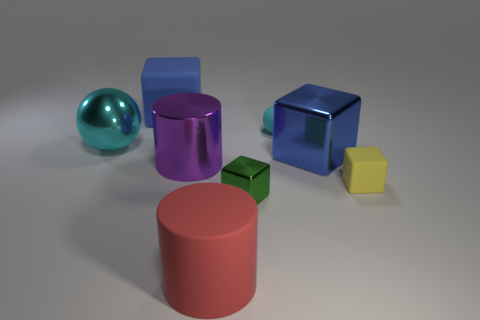Can you describe the color and shape variety among the objects? Certainly! The image displays a vibrant variety of colors and shapes. There is a cyan sphere, a purple cylinder, a blue cube, a green smaller cube, and a yellow cube, each contributing to a colorful and geometrically diverse ensemble. The different shapes and colors create an interesting visual contrast that could be used to explore concepts of variety, contrast, or composition in visual arts. 